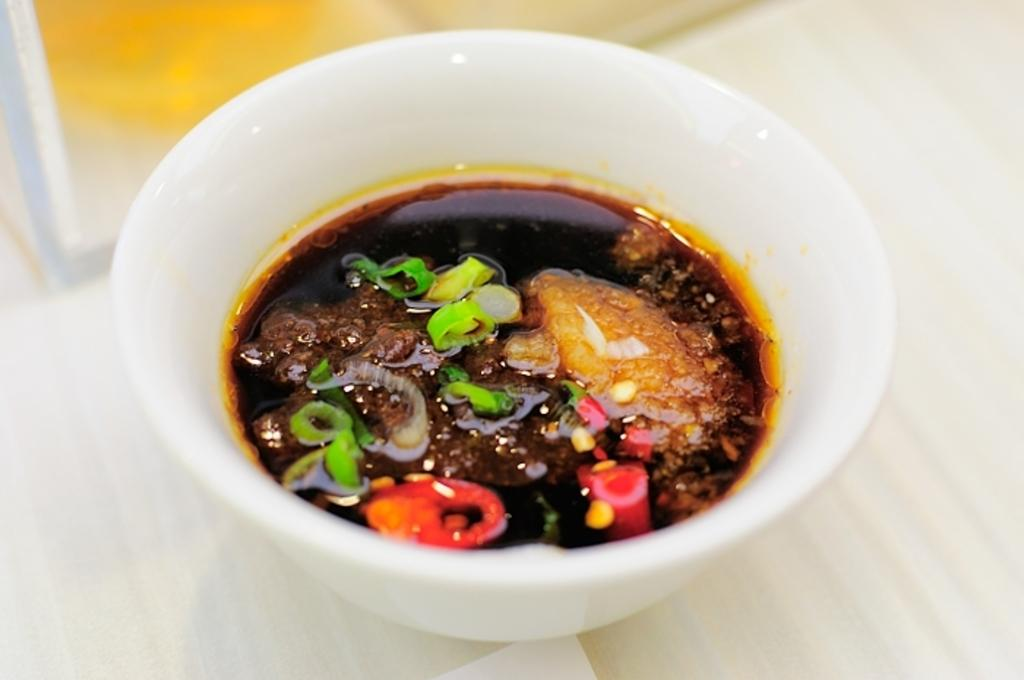What is in the bowl that is visible in the image? There is food in a bowl in the image. Where is the bowl located in the image? The bowl is on a platform in the image. What type of quiet attraction is present in the image? There is no quiet attraction present in the image; it only features a bowl of food on a platform. What type of rice can be seen in the image? There is no rice visible in the image; it only features a bowl of food. 